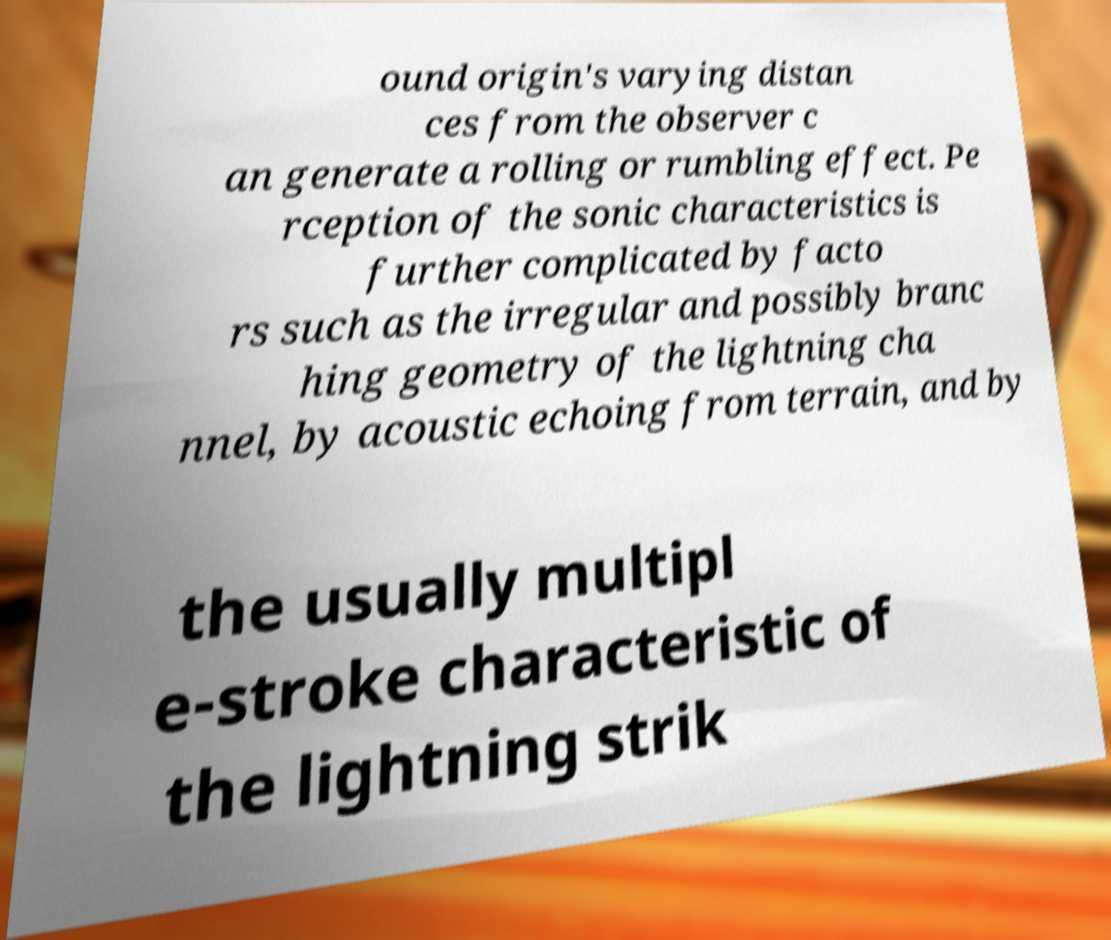Please read and relay the text visible in this image. What does it say? ound origin's varying distan ces from the observer c an generate a rolling or rumbling effect. Pe rception of the sonic characteristics is further complicated by facto rs such as the irregular and possibly branc hing geometry of the lightning cha nnel, by acoustic echoing from terrain, and by the usually multipl e-stroke characteristic of the lightning strik 